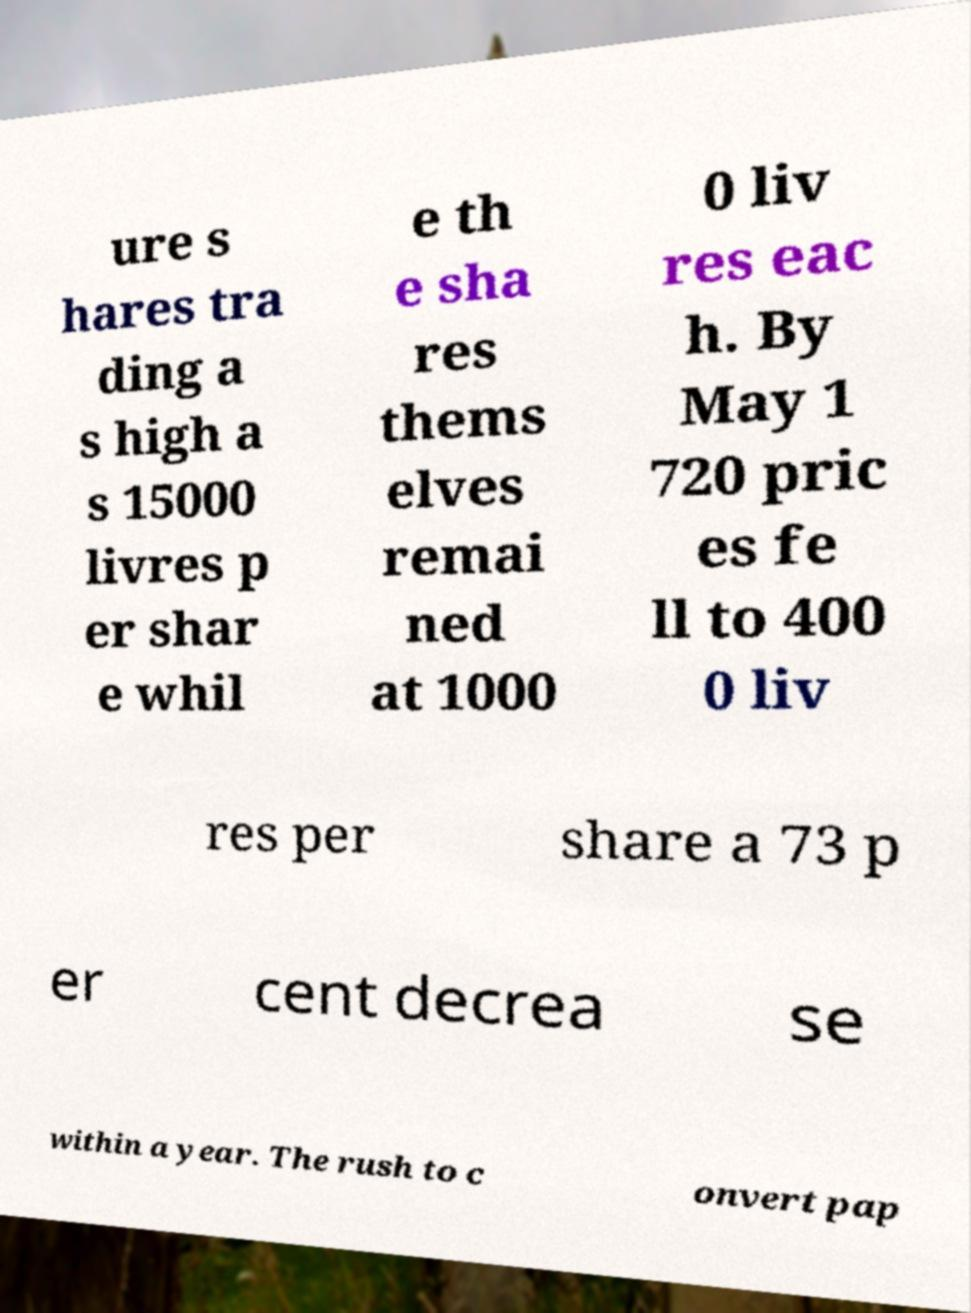Can you read and provide the text displayed in the image?This photo seems to have some interesting text. Can you extract and type it out for me? ure s hares tra ding a s high a s 15000 livres p er shar e whil e th e sha res thems elves remai ned at 1000 0 liv res eac h. By May 1 720 pric es fe ll to 400 0 liv res per share a 73 p er cent decrea se within a year. The rush to c onvert pap 